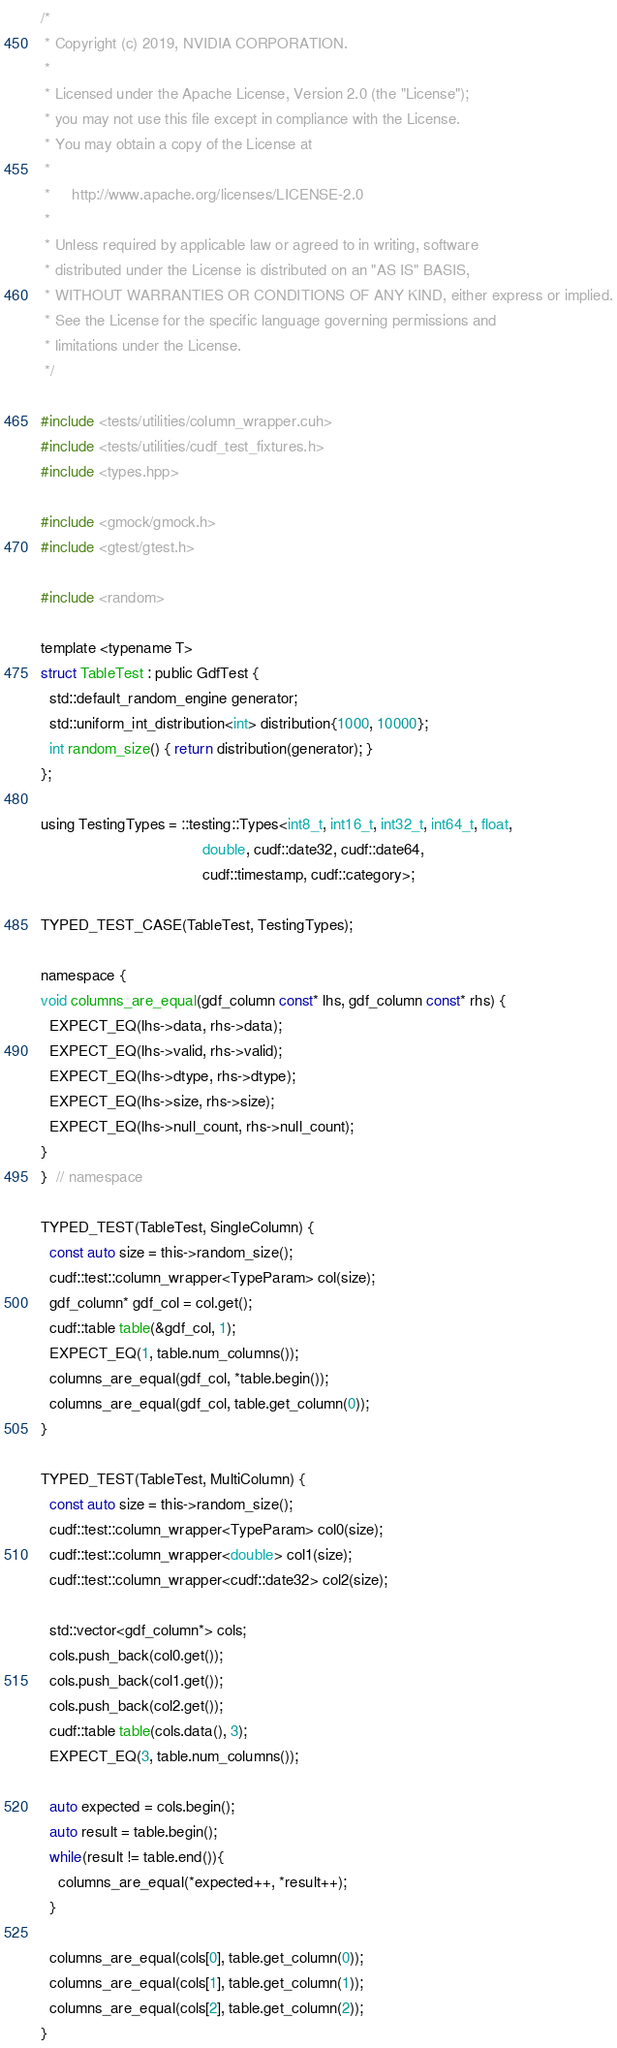Convert code to text. <code><loc_0><loc_0><loc_500><loc_500><_Cuda_>/*
 * Copyright (c) 2019, NVIDIA CORPORATION.
 *
 * Licensed under the Apache License, Version 2.0 (the "License");
 * you may not use this file except in compliance with the License.
 * You may obtain a copy of the License at
 *
 *     http://www.apache.org/licenses/LICENSE-2.0
 *
 * Unless required by applicable law or agreed to in writing, software
 * distributed under the License is distributed on an "AS IS" BASIS,
 * WITHOUT WARRANTIES OR CONDITIONS OF ANY KIND, either express or implied.
 * See the License for the specific language governing permissions and
 * limitations under the License.
 */

#include <tests/utilities/column_wrapper.cuh>
#include <tests/utilities/cudf_test_fixtures.h>
#include <types.hpp>

#include <gmock/gmock.h>
#include <gtest/gtest.h>

#include <random>

template <typename T>
struct TableTest : public GdfTest {
  std::default_random_engine generator;
  std::uniform_int_distribution<int> distribution{1000, 10000};
  int random_size() { return distribution(generator); }
};

using TestingTypes = ::testing::Types<int8_t, int16_t, int32_t, int64_t, float,
                                      double, cudf::date32, cudf::date64,
                                      cudf::timestamp, cudf::category>;

TYPED_TEST_CASE(TableTest, TestingTypes);

namespace {
void columns_are_equal(gdf_column const* lhs, gdf_column const* rhs) {
  EXPECT_EQ(lhs->data, rhs->data);
  EXPECT_EQ(lhs->valid, rhs->valid);
  EXPECT_EQ(lhs->dtype, rhs->dtype);
  EXPECT_EQ(lhs->size, rhs->size);
  EXPECT_EQ(lhs->null_count, rhs->null_count);
}
}  // namespace

TYPED_TEST(TableTest, SingleColumn) {
  const auto size = this->random_size();
  cudf::test::column_wrapper<TypeParam> col(size);
  gdf_column* gdf_col = col.get();
  cudf::table table(&gdf_col, 1);
  EXPECT_EQ(1, table.num_columns());
  columns_are_equal(gdf_col, *table.begin());
  columns_are_equal(gdf_col, table.get_column(0));
}

TYPED_TEST(TableTest, MultiColumn) {
  const auto size = this->random_size();
  cudf::test::column_wrapper<TypeParam> col0(size);
  cudf::test::column_wrapper<double> col1(size);
  cudf::test::column_wrapper<cudf::date32> col2(size);

  std::vector<gdf_column*> cols;
  cols.push_back(col0.get());
  cols.push_back(col1.get());
  cols.push_back(col2.get());
  cudf::table table(cols.data(), 3);
  EXPECT_EQ(3, table.num_columns());

  auto expected = cols.begin();
  auto result = table.begin();
  while(result != table.end()){
    columns_are_equal(*expected++, *result++);
  }

  columns_are_equal(cols[0], table.get_column(0));
  columns_are_equal(cols[1], table.get_column(1));
  columns_are_equal(cols[2], table.get_column(2));
}
</code> 